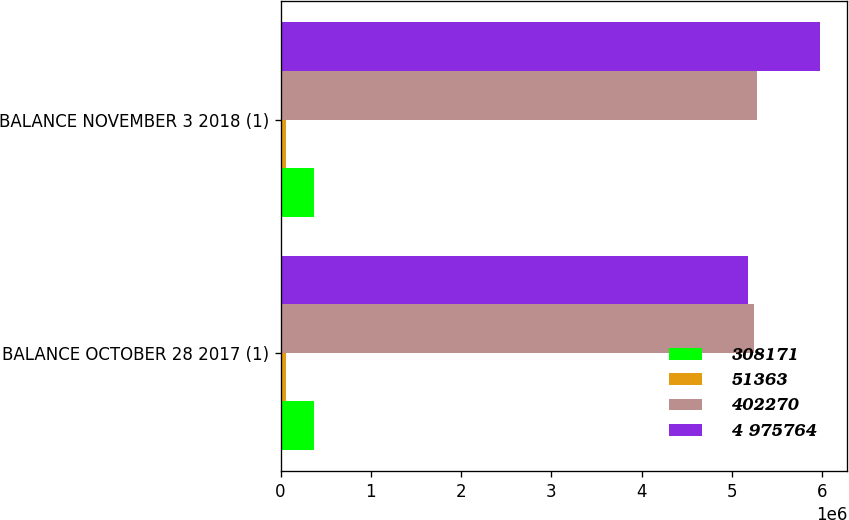<chart> <loc_0><loc_0><loc_500><loc_500><stacked_bar_chart><ecel><fcel>BALANCE OCTOBER 28 2017 (1)<fcel>BALANCE NOVEMBER 3 2018 (1)<nl><fcel>308171<fcel>368636<fcel>370160<nl><fcel>51363<fcel>61441<fcel>61694<nl><fcel>402270<fcel>5.25052e+06<fcel>5.28222e+06<nl><fcel>4 975764<fcel>5.17902e+06<fcel>5.9827e+06<nl></chart> 